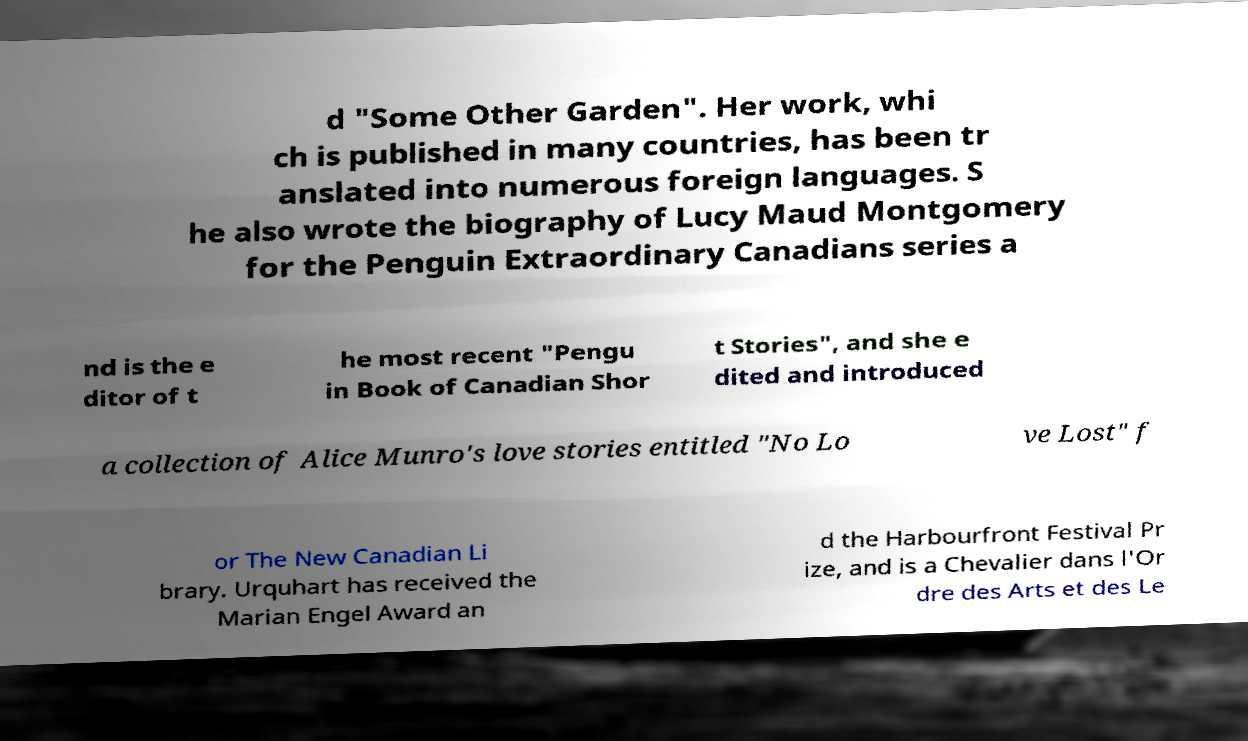Please read and relay the text visible in this image. What does it say? d "Some Other Garden". Her work, whi ch is published in many countries, has been tr anslated into numerous foreign languages. S he also wrote the biography of Lucy Maud Montgomery for the Penguin Extraordinary Canadians series a nd is the e ditor of t he most recent "Pengu in Book of Canadian Shor t Stories", and she e dited and introduced a collection of Alice Munro's love stories entitled "No Lo ve Lost" f or The New Canadian Li brary. Urquhart has received the Marian Engel Award an d the Harbourfront Festival Pr ize, and is a Chevalier dans l'Or dre des Arts et des Le 